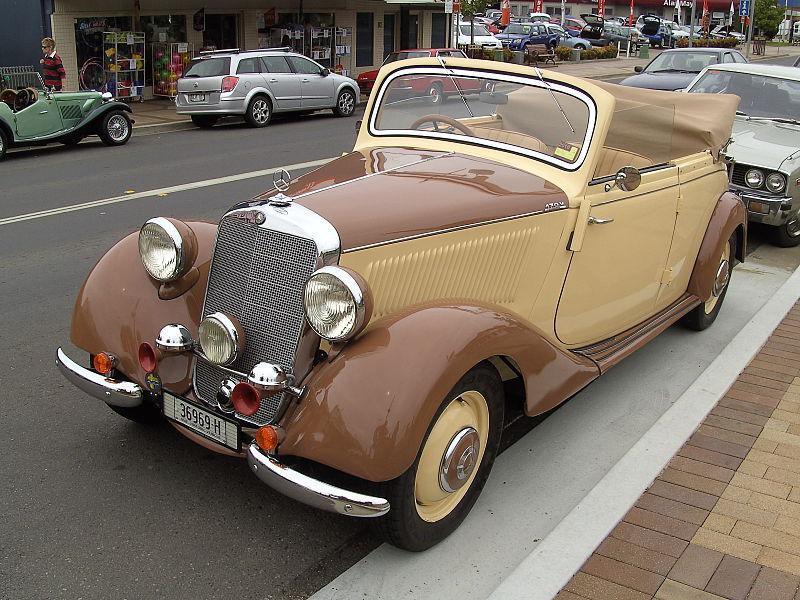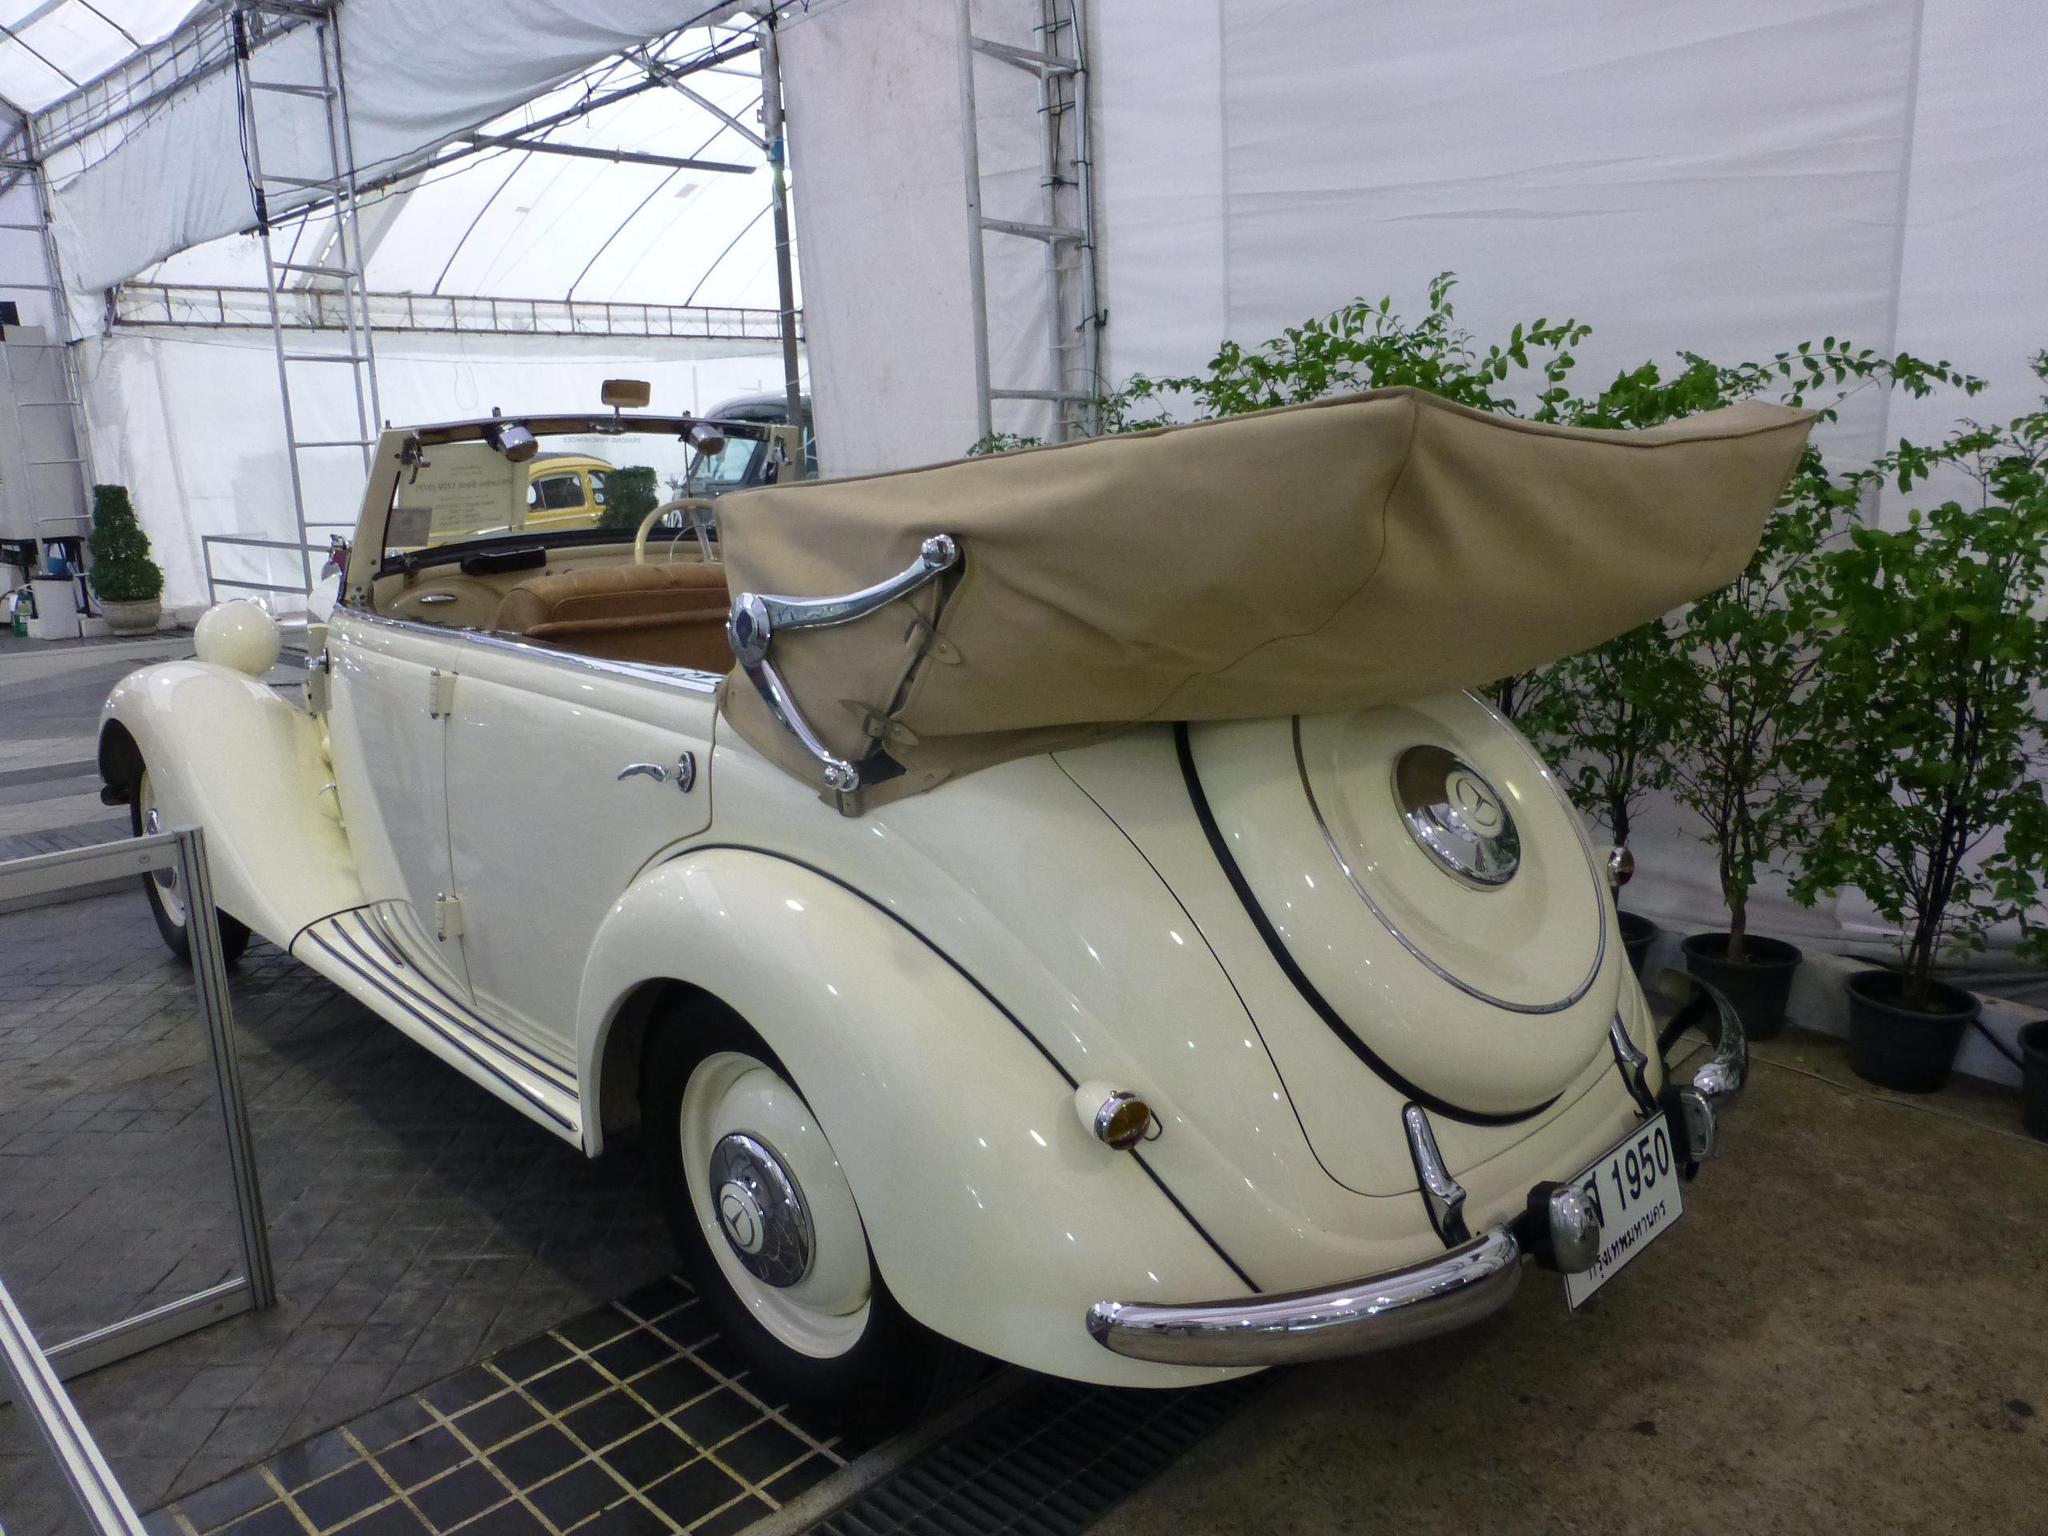The first image is the image on the left, the second image is the image on the right. Considering the images on both sides, is "Both images show shiny painted exteriors of antique convertibles in good condition." valid? Answer yes or no. Yes. The first image is the image on the left, the second image is the image on the right. For the images shown, is this caption "There are multiple cars behind a parked classic car in one of the images." true? Answer yes or no. Yes. 